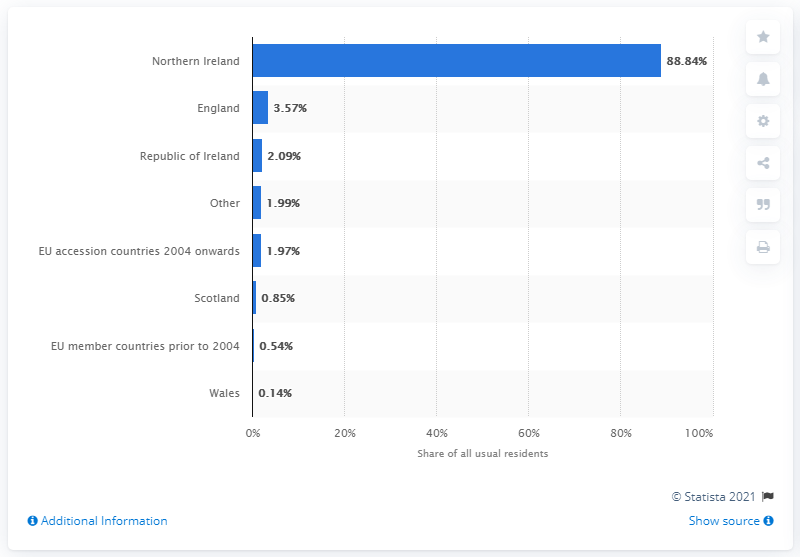Give some essential details in this illustration. The average of all counties except Northern Ireland is 1.59. 